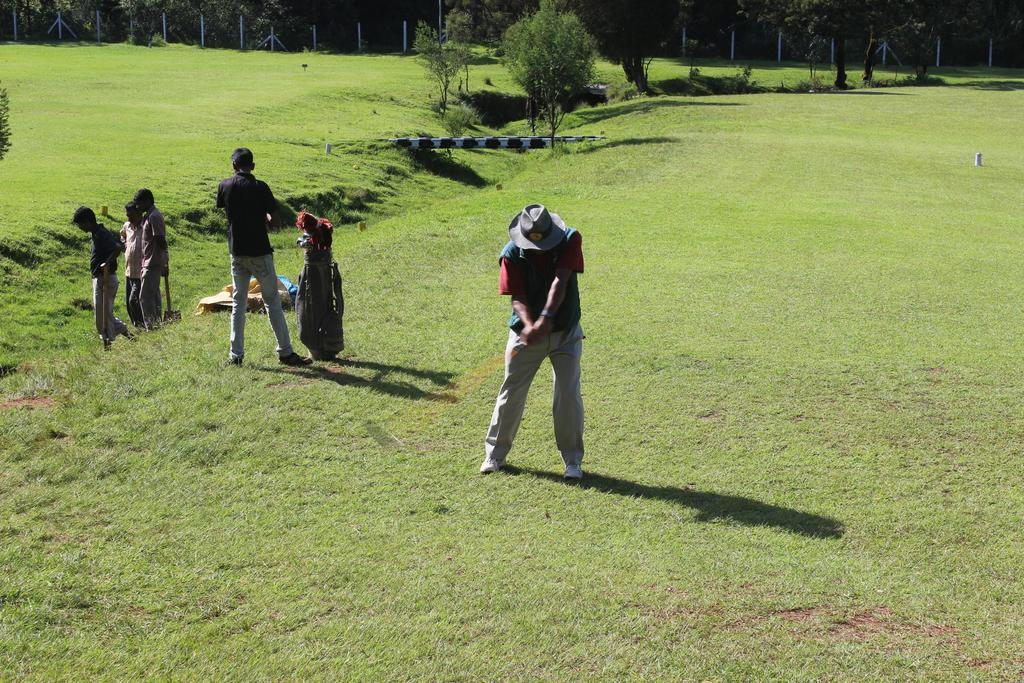What type of vegetation can be seen in the image? There are trees in the image. What is the bag used for in the image? The purpose of the bag is not specified in the image. Can you describe the objects in the image? There are objects in the image, but their specific nature is not mentioned in the facts. What are the people standing on in the image? The people are standing on the grass in the image. What is the purpose of the fence in the image? The purpose of the fence is not specified in the image. Can you tell me how many goldfish are swimming in the club's division in the image? There are no goldfish, clubs, or divisions present in the image. 